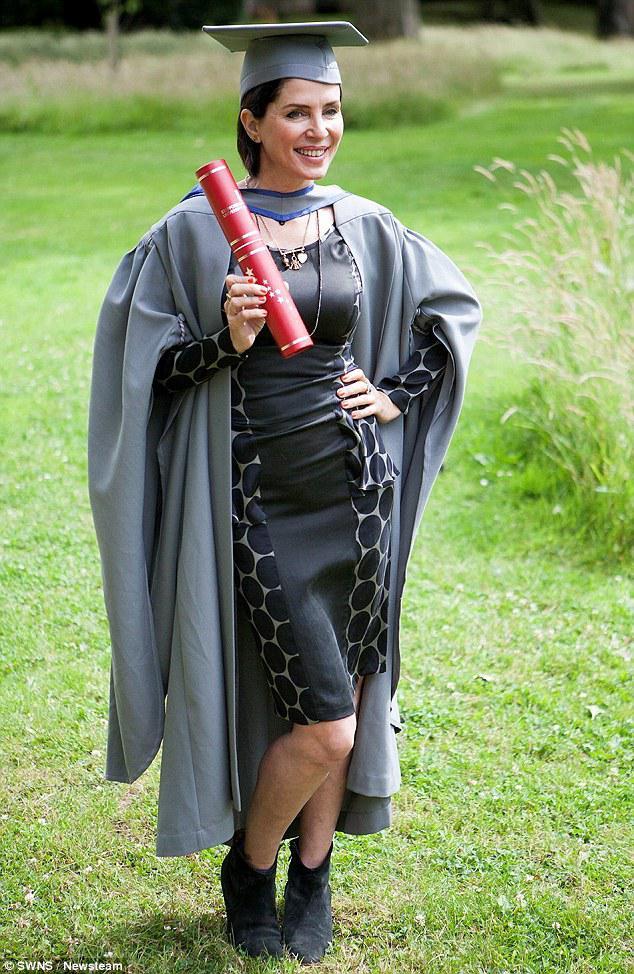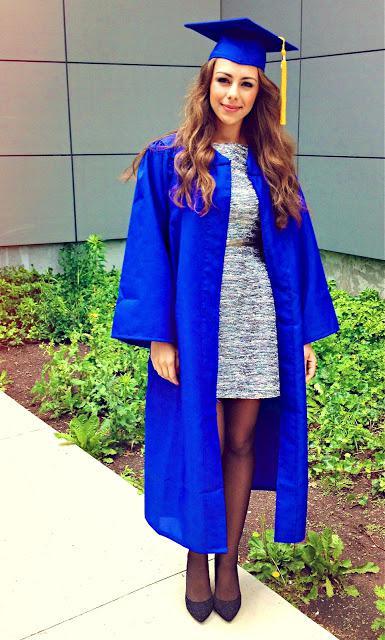The first image is the image on the left, the second image is the image on the right. Examine the images to the left and right. Is the description "There are total of three graduates." accurate? Answer yes or no. No. 